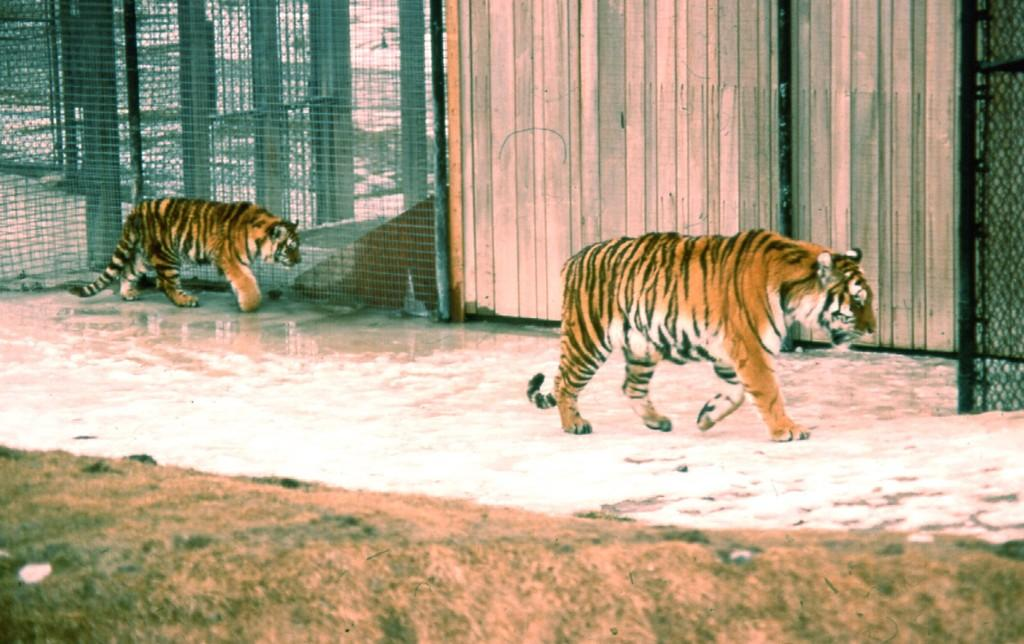What animals can be seen in the image? There are tigers in the image. What are the tigers doing in the image? The tigers are walking on a floor. What can be seen in the background of the image? There is fencing and a wooden wall in the background of the image. What type of terrain is visible at the bottom of the image? There is a grassland at the bottom of the image. What type of shade is provided by the tiger in the image? There is no shade provided by the tiger in the image, as it is walking on a floor and not providing any shelter or coverage. 